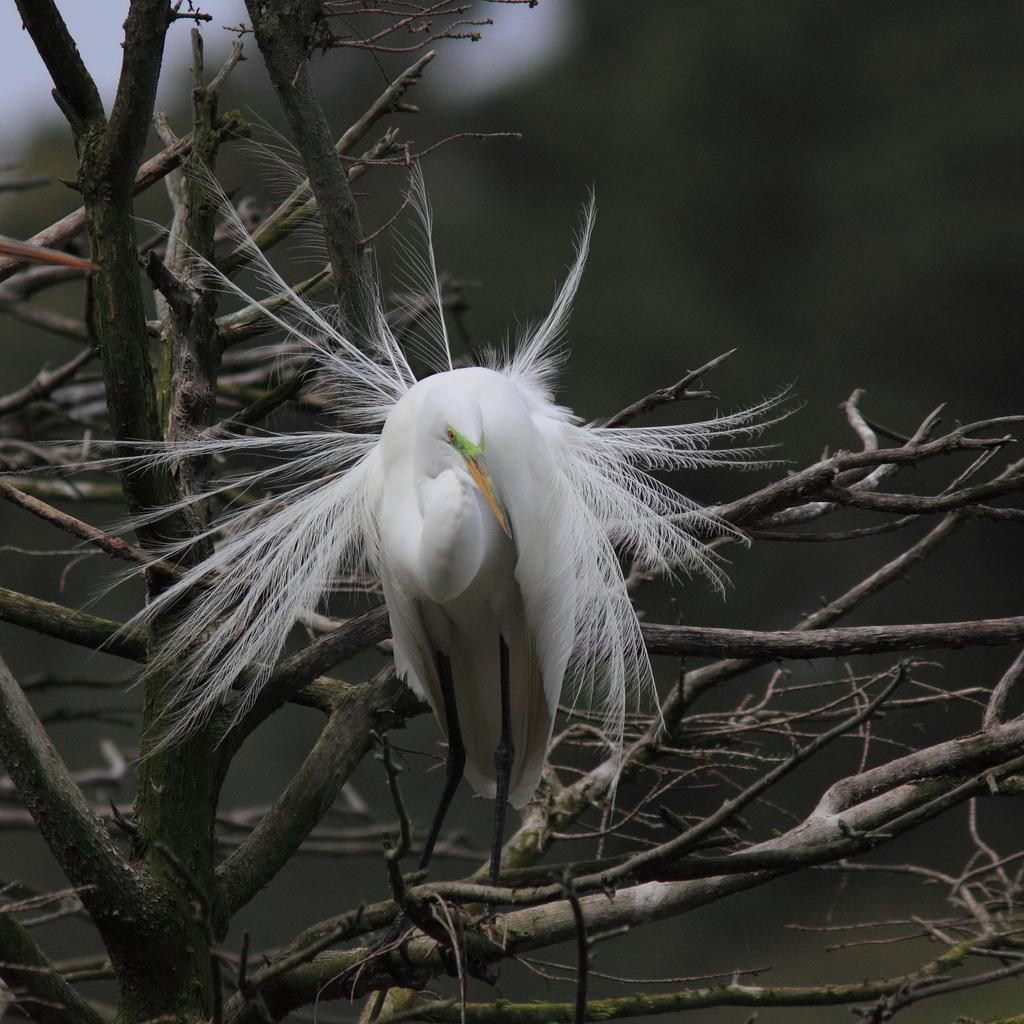What type of bird is in the image? There is a great egret in the image. Where is the great egret located in the image? The great egret is present on a branch of a tree. What type of test can be seen being conducted in the image? There is no test present in the image; it features a great egret on a tree branch. How much wealth is visible in the image? There is no indication of wealth in the image, as it only shows a great egret on a tree branch. 